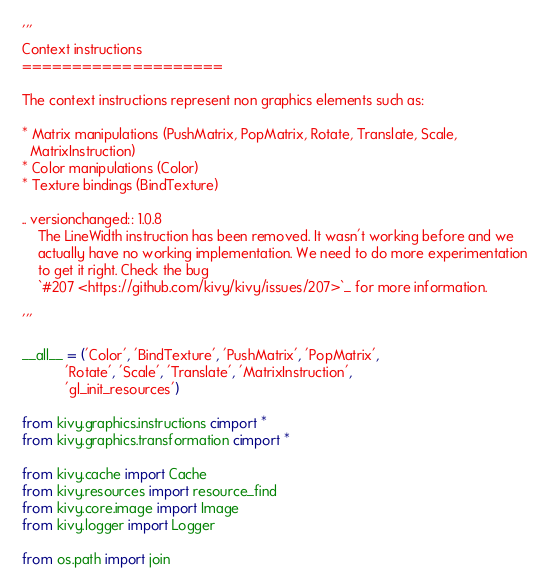Convert code to text. <code><loc_0><loc_0><loc_500><loc_500><_Cython_>'''
Context instructions
====================

The context instructions represent non graphics elements such as:

* Matrix manipulations (PushMatrix, PopMatrix, Rotate, Translate, Scale,
  MatrixInstruction)
* Color manipulations (Color)
* Texture bindings (BindTexture)

.. versionchanged:: 1.0.8
    The LineWidth instruction has been removed. It wasn't working before and we
    actually have no working implementation. We need to do more experimentation
    to get it right. Check the bug
    `#207 <https://github.com/kivy/kivy/issues/207>`_ for more information.

'''

__all__ = ('Color', 'BindTexture', 'PushMatrix', 'PopMatrix',
           'Rotate', 'Scale', 'Translate', 'MatrixInstruction',
           'gl_init_resources')

from kivy.graphics.instructions cimport *
from kivy.graphics.transformation cimport *

from kivy.cache import Cache
from kivy.resources import resource_find
from kivy.core.image import Image
from kivy.logger import Logger

from os.path import join</code> 